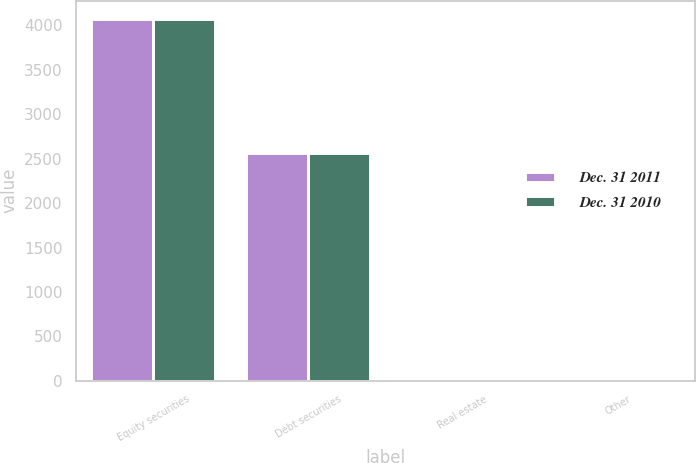Convert chart. <chart><loc_0><loc_0><loc_500><loc_500><stacked_bar_chart><ecel><fcel>Equity securities<fcel>Debt securities<fcel>Real estate<fcel>Other<nl><fcel>Dec. 31 2011<fcel>4075<fcel>2560<fcel>10<fcel>10<nl><fcel>Dec. 31 2010<fcel>4075<fcel>2560<fcel>10<fcel>10<nl></chart> 